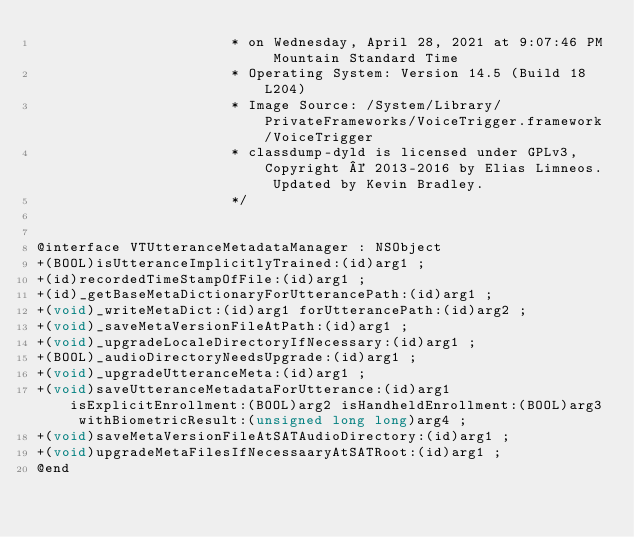Convert code to text. <code><loc_0><loc_0><loc_500><loc_500><_C_>                       * on Wednesday, April 28, 2021 at 9:07:46 PM Mountain Standard Time
                       * Operating System: Version 14.5 (Build 18L204)
                       * Image Source: /System/Library/PrivateFrameworks/VoiceTrigger.framework/VoiceTrigger
                       * classdump-dyld is licensed under GPLv3, Copyright © 2013-2016 by Elias Limneos. Updated by Kevin Bradley.
                       */


@interface VTUtteranceMetadataManager : NSObject
+(BOOL)isUtteranceImplicitlyTrained:(id)arg1 ;
+(id)recordedTimeStampOfFile:(id)arg1 ;
+(id)_getBaseMetaDictionaryForUtterancePath:(id)arg1 ;
+(void)_writeMetaDict:(id)arg1 forUtterancePath:(id)arg2 ;
+(void)_saveMetaVersionFileAtPath:(id)arg1 ;
+(void)_upgradeLocaleDirectoryIfNecessary:(id)arg1 ;
+(BOOL)_audioDirectoryNeedsUpgrade:(id)arg1 ;
+(void)_upgradeUtteranceMeta:(id)arg1 ;
+(void)saveUtteranceMetadataForUtterance:(id)arg1 isExplicitEnrollment:(BOOL)arg2 isHandheldEnrollment:(BOOL)arg3 withBiometricResult:(unsigned long long)arg4 ;
+(void)saveMetaVersionFileAtSATAudioDirectory:(id)arg1 ;
+(void)upgradeMetaFilesIfNecessaaryAtSATRoot:(id)arg1 ;
@end

</code> 